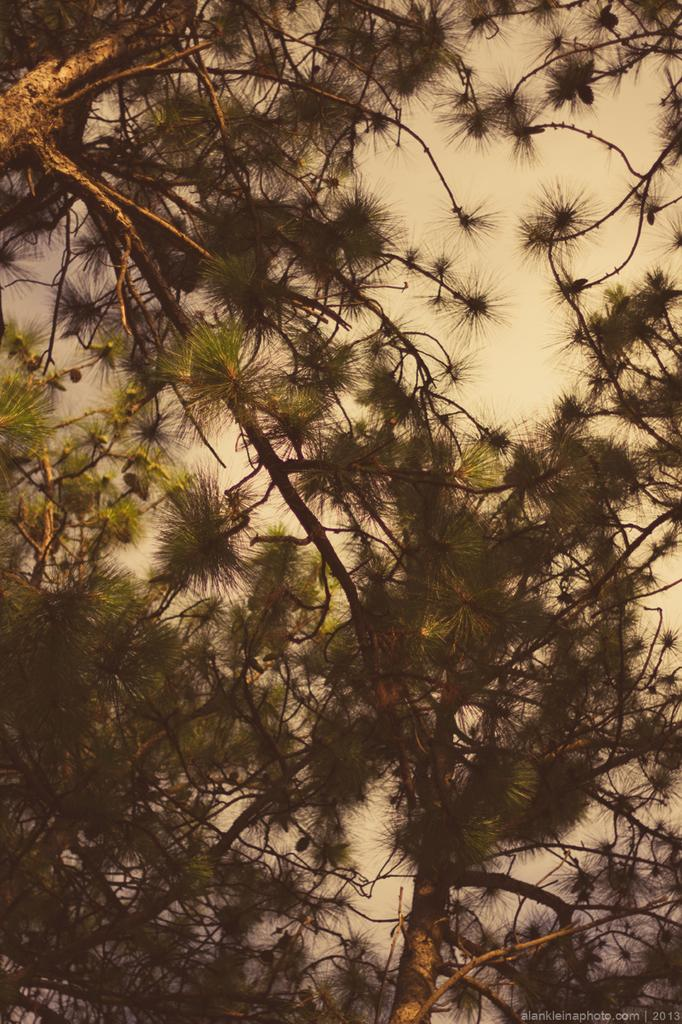What type of vegetation can be seen in the image? There are trees in the image. What is the condition of the sky in the image? The sky is cloudy in the image. What type of animal can be seen in the image? There is no animal present in the image; it only features trees and a cloudy sky. What religious belief is depicted in the image? There is no religious belief depicted in the image; it only features trees and a cloudy sky. 